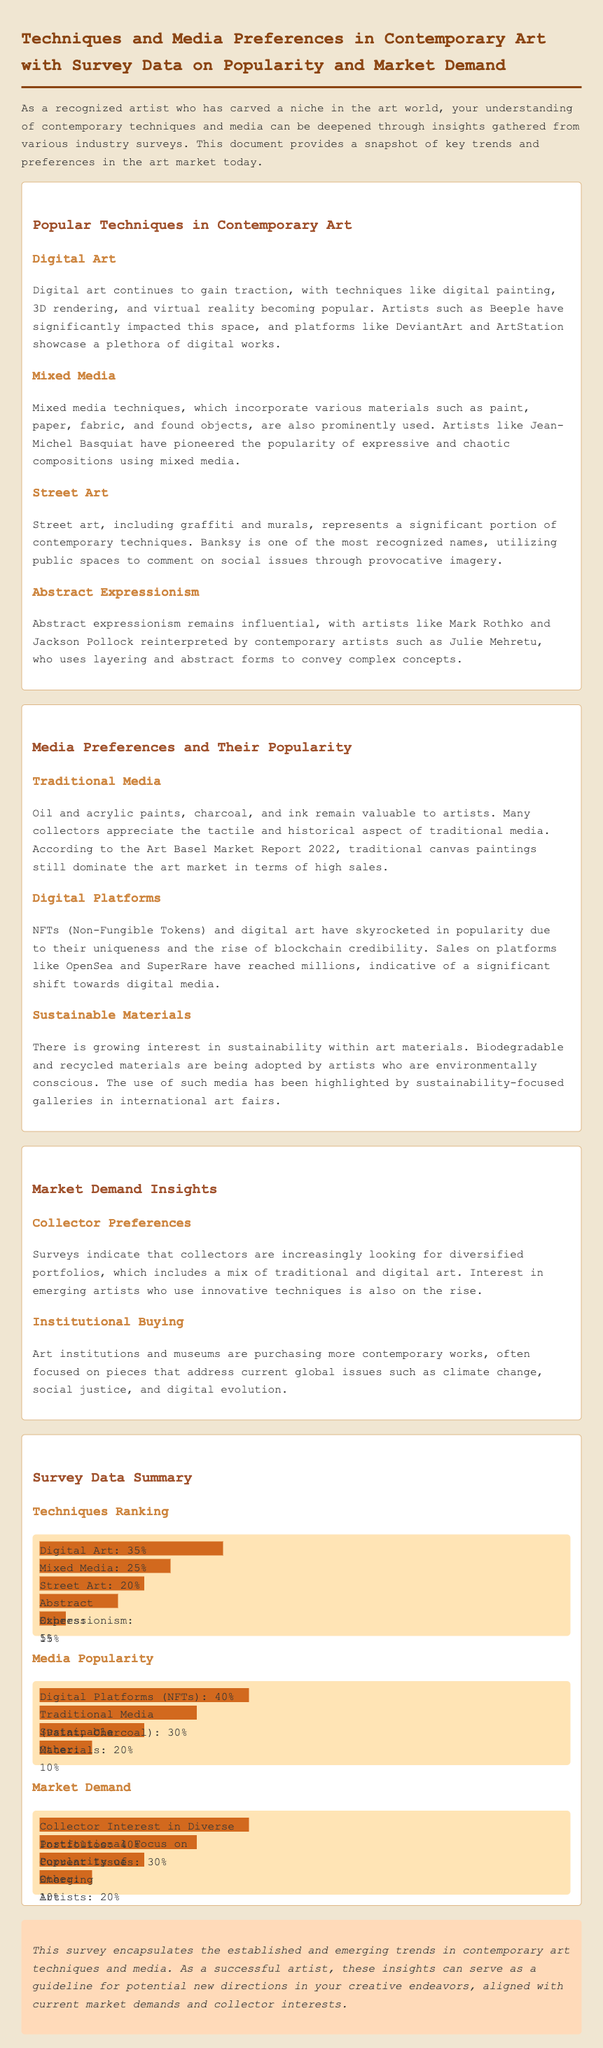what is the percentage of popularity for Digital Art? The percentage of popularity for Digital Art is explicitly stated in the survey data summary under Techniques Ranking.
Answer: 35% which artist is mentioned in relation to Digital Art? The document lists Beeple as a prominent figure influencing the digital art space.
Answer: Beeple what percentage do Traditional Media hold in media popularity? The document provides a clear percentage for Traditional Media in the Media Popularity section.
Answer: 30% who is a notable street artist mentioned in the document? The document highlights Banksy as a significant name in street art.
Answer: Banksy what is the market demand percentage for Collector Interest in Diverse Portfolios? The document specifies the percentage related to Collector Interest in the Market Demand section.
Answer: 40% which technique incorporates various materials like paint, paper, and fabric? The section on Popular Techniques describes Mixed Media as incorporating these materials.
Answer: Mixed Media what is the market focus of institutions and museums according to the document? The document states that institutions focus on art addressing current global issues.
Answer: Current global issues which contemporary technique ranks third in popularity? The survey data outlines the ranking of techniques, and Street Art is mentioned as the third.
Answer: Street Art 